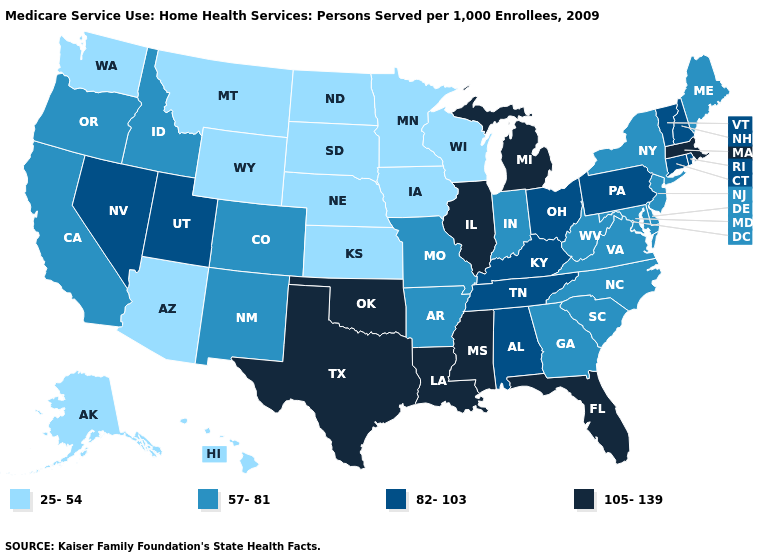What is the highest value in the USA?
Concise answer only. 105-139. How many symbols are there in the legend?
Be succinct. 4. How many symbols are there in the legend?
Short answer required. 4. Does New York have the highest value in the Northeast?
Short answer required. No. Name the states that have a value in the range 57-81?
Keep it brief. Arkansas, California, Colorado, Delaware, Georgia, Idaho, Indiana, Maine, Maryland, Missouri, New Jersey, New Mexico, New York, North Carolina, Oregon, South Carolina, Virginia, West Virginia. Among the states that border Alabama , which have the highest value?
Quick response, please. Florida, Mississippi. Among the states that border Alabama , which have the lowest value?
Concise answer only. Georgia. Which states have the lowest value in the West?
Answer briefly. Alaska, Arizona, Hawaii, Montana, Washington, Wyoming. Does North Dakota have the highest value in the USA?
Short answer required. No. What is the lowest value in the MidWest?
Quick response, please. 25-54. Which states have the lowest value in the South?
Answer briefly. Arkansas, Delaware, Georgia, Maryland, North Carolina, South Carolina, Virginia, West Virginia. Name the states that have a value in the range 82-103?
Be succinct. Alabama, Connecticut, Kentucky, Nevada, New Hampshire, Ohio, Pennsylvania, Rhode Island, Tennessee, Utah, Vermont. Which states have the lowest value in the USA?
Answer briefly. Alaska, Arizona, Hawaii, Iowa, Kansas, Minnesota, Montana, Nebraska, North Dakota, South Dakota, Washington, Wisconsin, Wyoming. What is the lowest value in the South?
Quick response, please. 57-81. Name the states that have a value in the range 57-81?
Short answer required. Arkansas, California, Colorado, Delaware, Georgia, Idaho, Indiana, Maine, Maryland, Missouri, New Jersey, New Mexico, New York, North Carolina, Oregon, South Carolina, Virginia, West Virginia. 